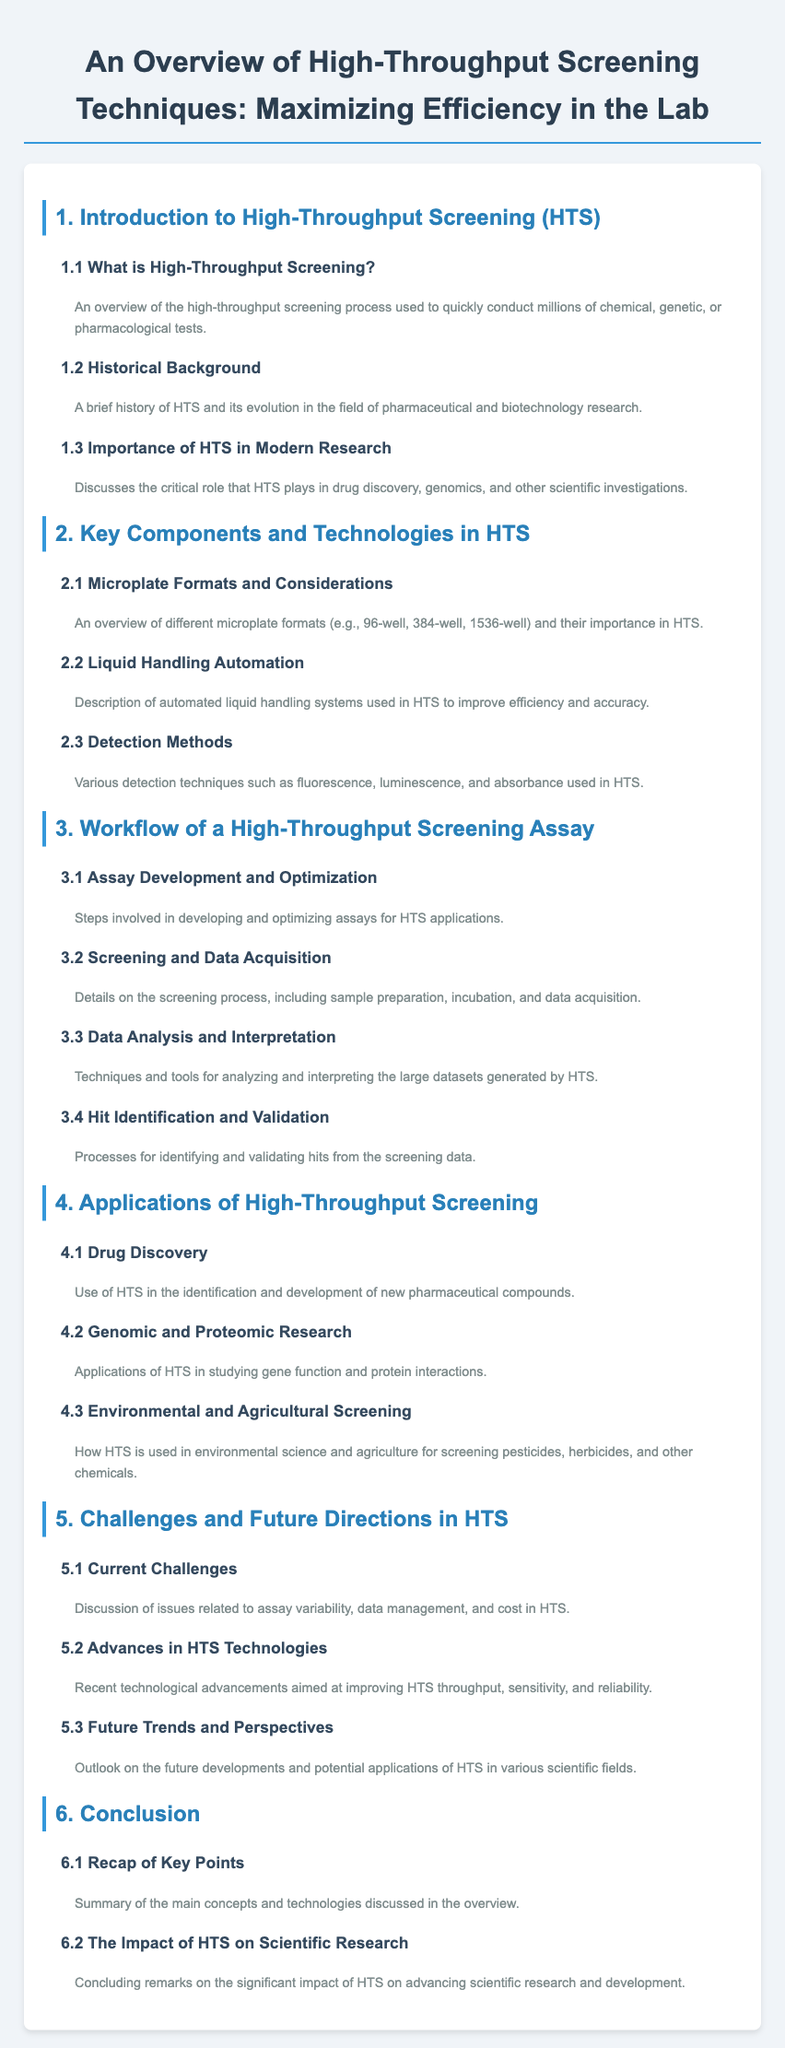What is High-Throughput Screening? It is described in section 1.1, which provides an overview of the high-throughput screening process.
Answer: An overview of the high-throughput screening process used to quickly conduct millions of chemical, genetic, or pharmacological tests What are the different microplate formats mentioned? Section 2.1 discusses various microplate formats relevant to HTS.
Answer: 96-well, 384-well, 1536-well What is one example of a detection method used in HTS? The document in section 2.3 lists various detection techniques.
Answer: Fluorescence What is a key challenge in HTS? Section 5.1 discusses current challenges faced in high-throughput screening.
Answer: Assay variability What does section 4.1 cover? This section focuses on the specific application of HTS in a particular field.
Answer: Drug Discovery How many subsections are in the Introduction to High-Throughput Screening? Section 1 contains 3 subsections addressing different aspects.
Answer: 3 What is the main focus of section 5.2? This section highlights recent advancements in HTS technologies.
Answer: Advances in HTS Technologies What is discussed in section 6.2? This subsection provides concluding remarks on a significant topic in the document.
Answer: The Impact of HTS on Scientific Research 